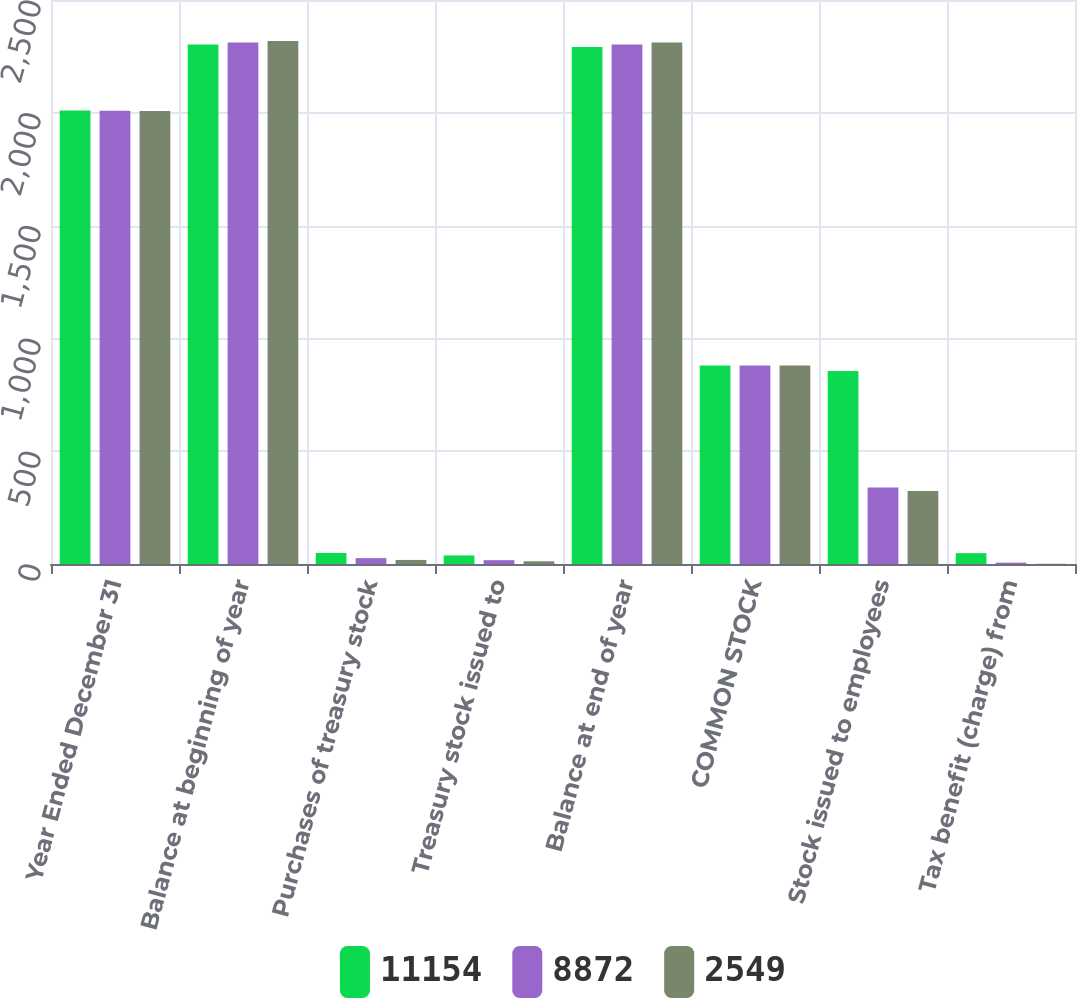Convert chart to OTSL. <chart><loc_0><loc_0><loc_500><loc_500><stacked_bar_chart><ecel><fcel>Year Ended December 31<fcel>Balance at beginning of year<fcel>Purchases of treasury stock<fcel>Treasury stock issued to<fcel>Balance at end of year<fcel>COMMON STOCK<fcel>Stock issued to employees<fcel>Tax benefit (charge) from<nl><fcel>11154<fcel>2010<fcel>2303<fcel>49<fcel>38<fcel>2292<fcel>880<fcel>855<fcel>48<nl><fcel>8872<fcel>2009<fcel>2312<fcel>26<fcel>17<fcel>2303<fcel>880<fcel>339<fcel>6<nl><fcel>2549<fcel>2008<fcel>2318<fcel>18<fcel>12<fcel>2312<fcel>880<fcel>324<fcel>1<nl></chart> 